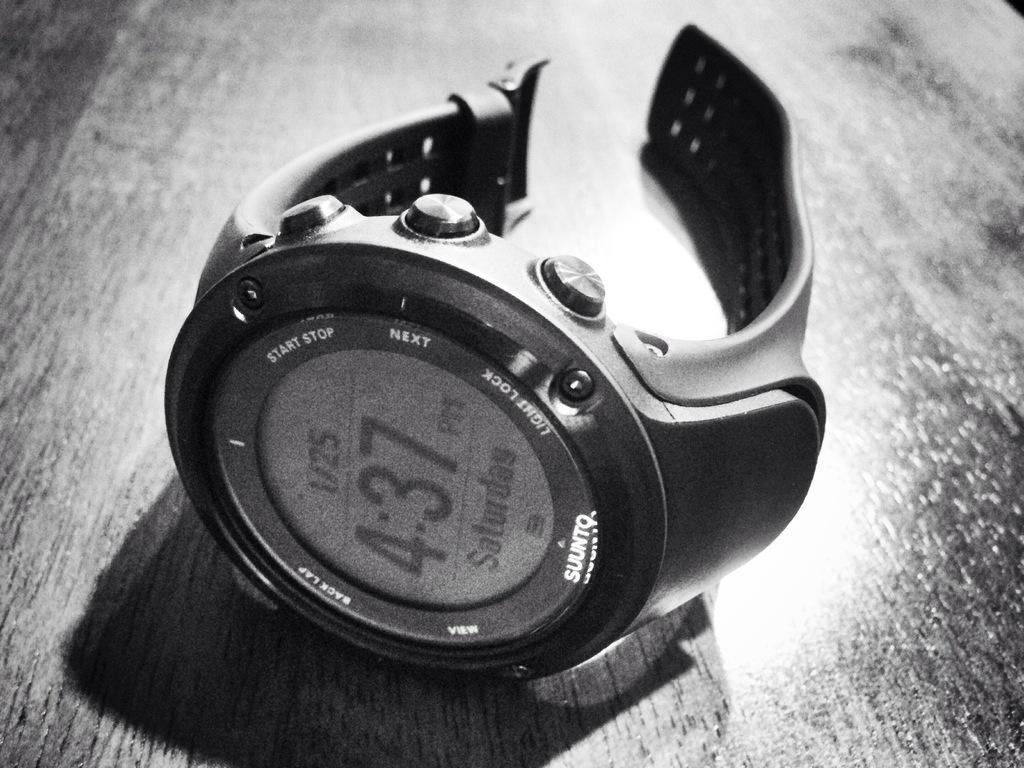<image>
Give a short and clear explanation of the subsequent image. A Suunto brand watch lies on its side on a wooden table. 